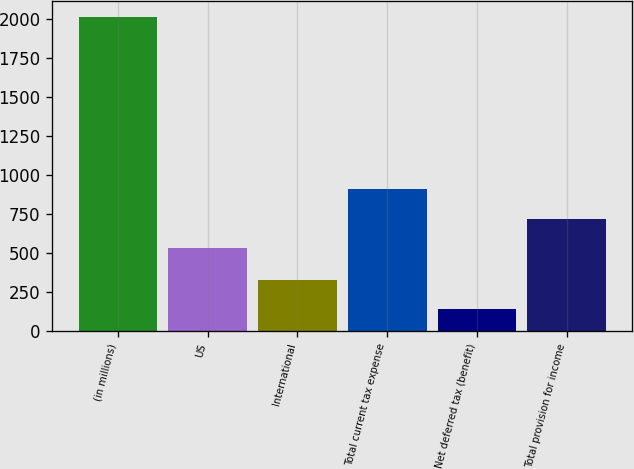Convert chart. <chart><loc_0><loc_0><loc_500><loc_500><bar_chart><fcel>(in millions)<fcel>US<fcel>International<fcel>Total current tax expense<fcel>Net deferred tax (benefit)<fcel>Total provision for income<nl><fcel>2014<fcel>532<fcel>327.4<fcel>906.8<fcel>140<fcel>719.4<nl></chart> 